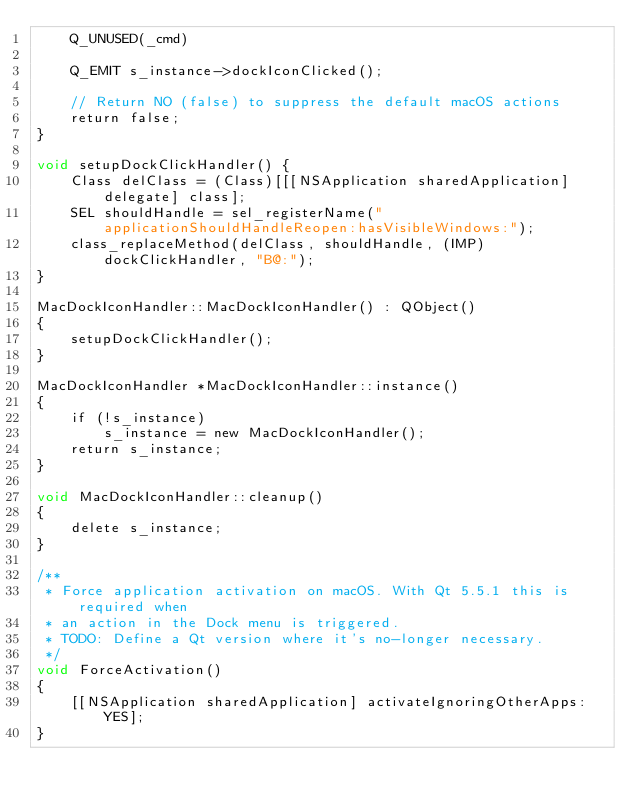<code> <loc_0><loc_0><loc_500><loc_500><_ObjectiveC_>    Q_UNUSED(_cmd)

    Q_EMIT s_instance->dockIconClicked();

    // Return NO (false) to suppress the default macOS actions
    return false;
}

void setupDockClickHandler() {
    Class delClass = (Class)[[[NSApplication sharedApplication] delegate] class];
    SEL shouldHandle = sel_registerName("applicationShouldHandleReopen:hasVisibleWindows:");
    class_replaceMethod(delClass, shouldHandle, (IMP)dockClickHandler, "B@:");
}

MacDockIconHandler::MacDockIconHandler() : QObject()
{
    setupDockClickHandler();
}

MacDockIconHandler *MacDockIconHandler::instance()
{
    if (!s_instance)
        s_instance = new MacDockIconHandler();
    return s_instance;
}

void MacDockIconHandler::cleanup()
{
    delete s_instance;
}

/**
 * Force application activation on macOS. With Qt 5.5.1 this is required when
 * an action in the Dock menu is triggered.
 * TODO: Define a Qt version where it's no-longer necessary.
 */
void ForceActivation()
{
    [[NSApplication sharedApplication] activateIgnoringOtherApps:YES];
}
</code> 